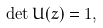Convert formula to latex. <formula><loc_0><loc_0><loc_500><loc_500>\det U ( z ) = 1 ,</formula> 